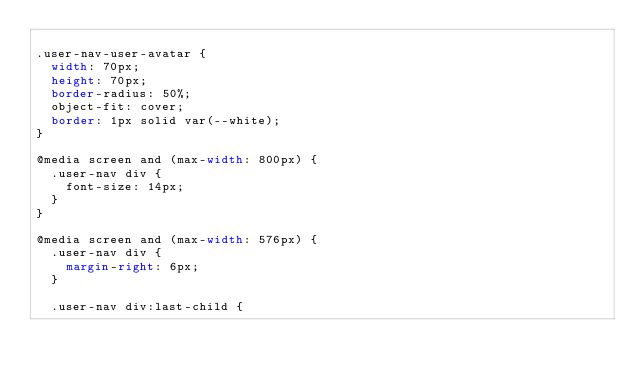Convert code to text. <code><loc_0><loc_0><loc_500><loc_500><_CSS_>
.user-nav-user-avatar {
  width: 70px;
  height: 70px;
  border-radius: 50%;
  object-fit: cover;
  border: 1px solid var(--white);
}

@media screen and (max-width: 800px) {
  .user-nav div {
    font-size: 14px;
  }
}

@media screen and (max-width: 576px) {
  .user-nav div {
    margin-right: 6px;
  }

  .user-nav div:last-child {</code> 